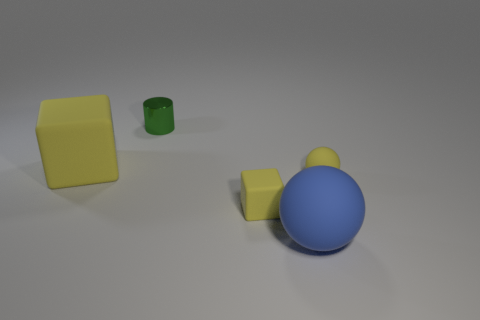Add 2 tiny cyan metal balls. How many objects exist? 7 Subtract all balls. How many objects are left? 3 Add 5 large blue objects. How many large blue objects exist? 6 Subtract 0 red balls. How many objects are left? 5 Subtract all small green matte cylinders. Subtract all tiny matte things. How many objects are left? 3 Add 3 tiny yellow rubber things. How many tiny yellow rubber things are left? 5 